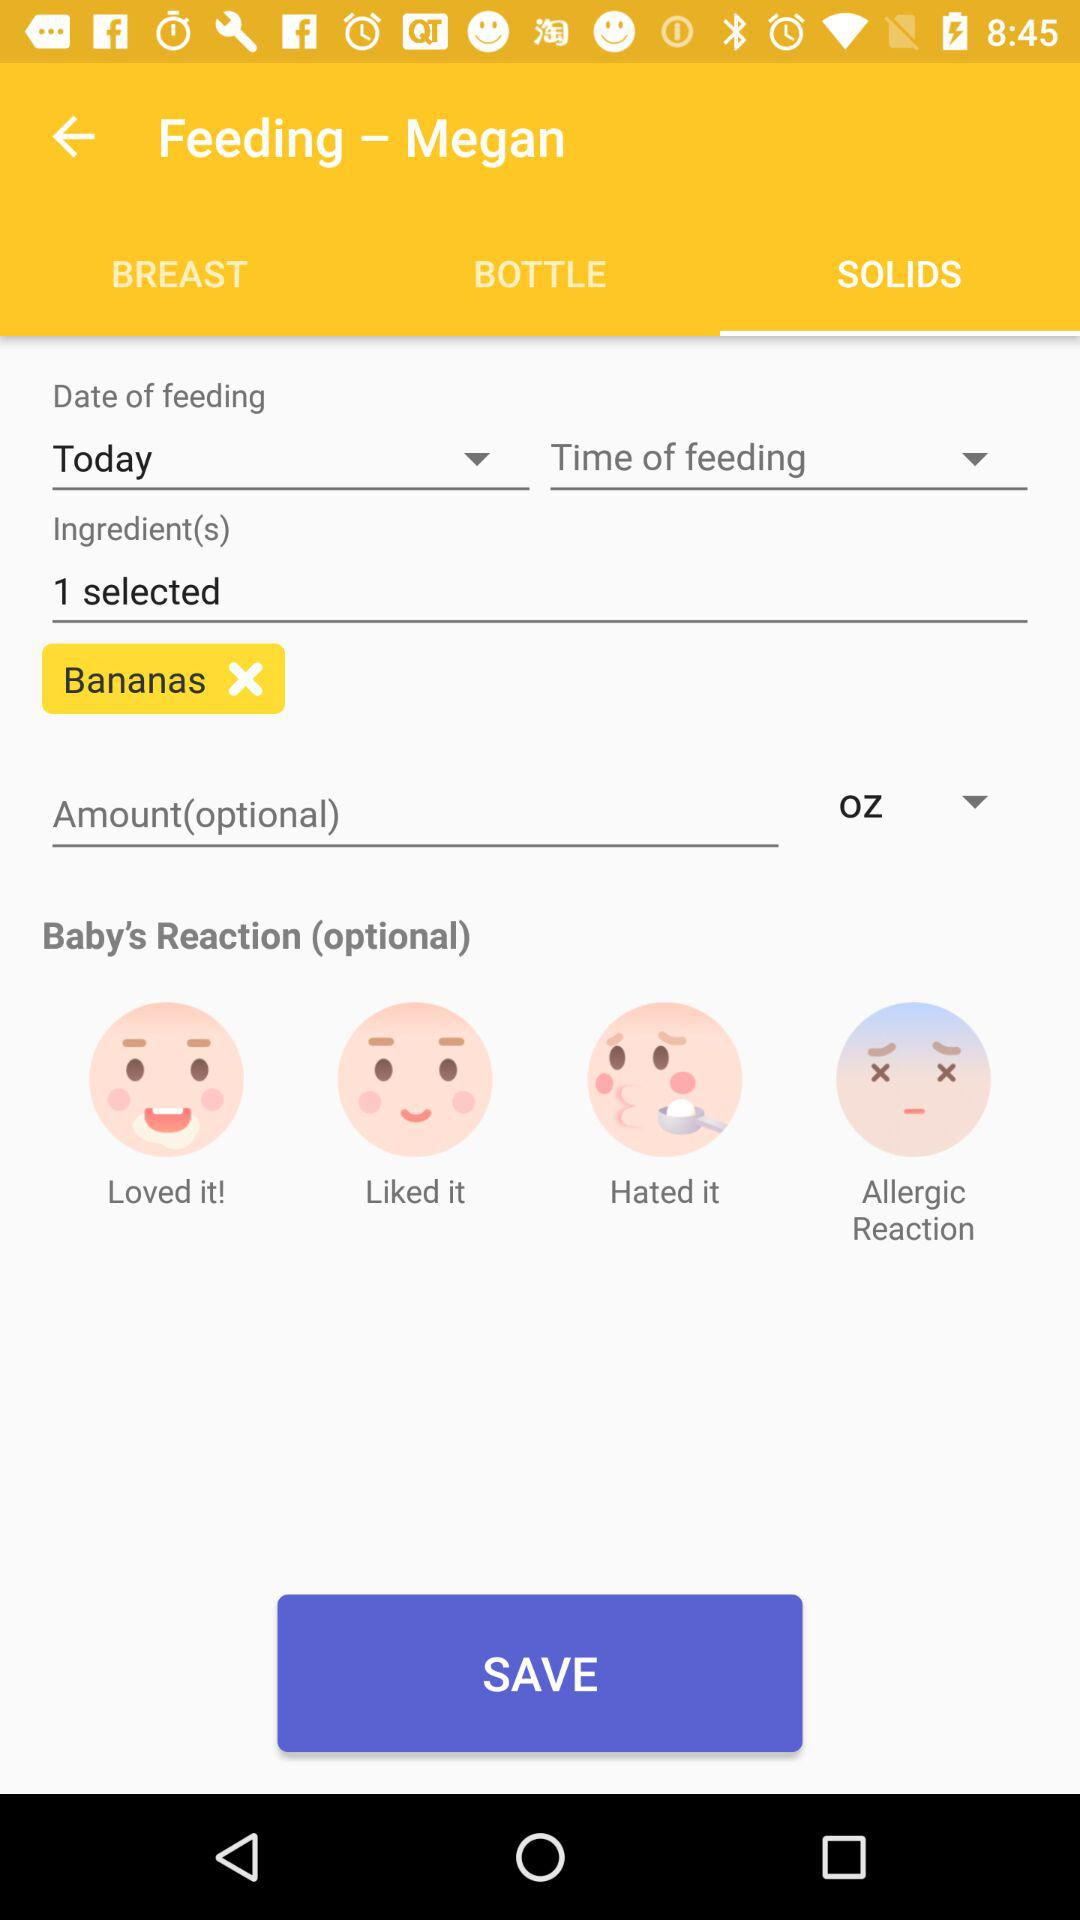What are the names of the selected ingredients? The selected ingredient is banana. 